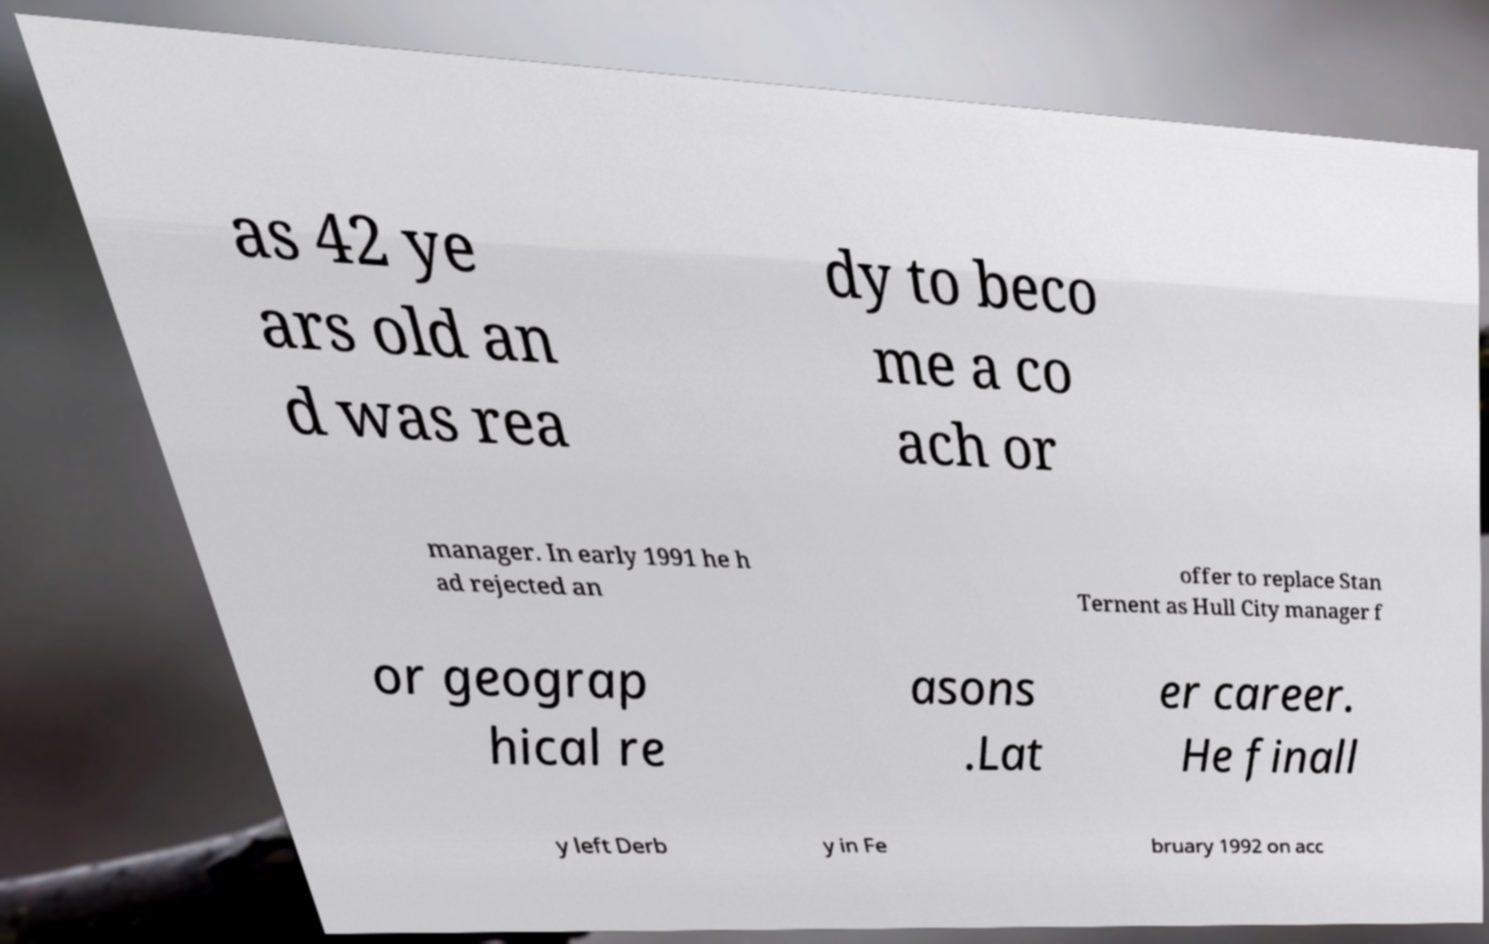What messages or text are displayed in this image? I need them in a readable, typed format. as 42 ye ars old an d was rea dy to beco me a co ach or manager. In early 1991 he h ad rejected an offer to replace Stan Ternent as Hull City manager f or geograp hical re asons .Lat er career. He finall y left Derb y in Fe bruary 1992 on acc 